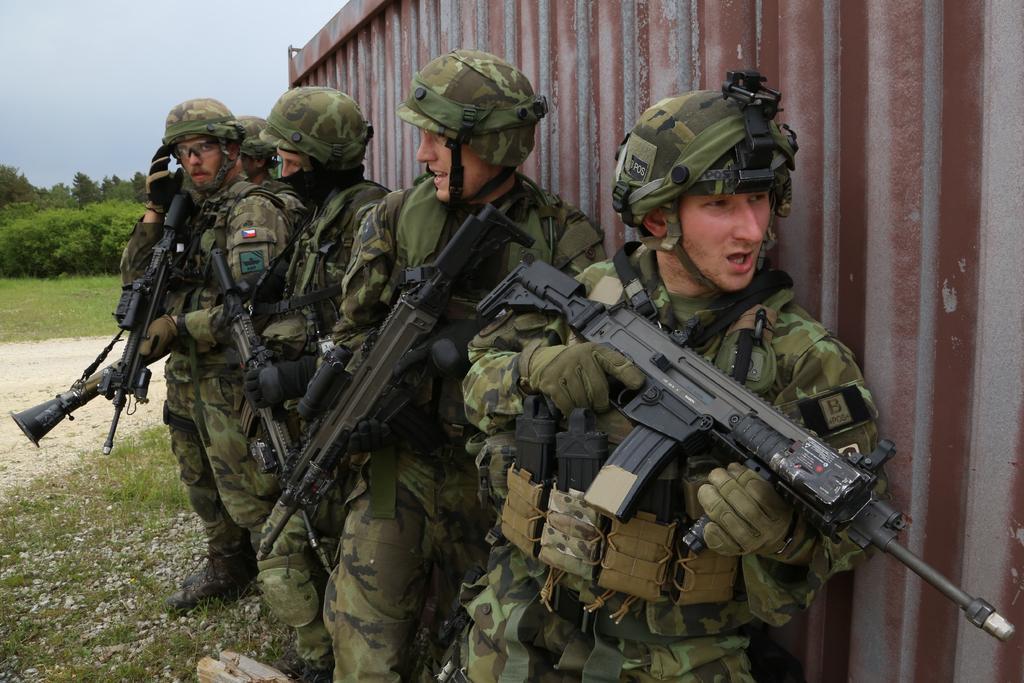Please provide a concise description of this image. In this image there are persons standing and holding guns in their hands, there is grass on the ground and there are stones on the ground. On the right side there is a container which is brown in colour. In the background there are trees, there is grass on the ground and the sky is cloudy. 